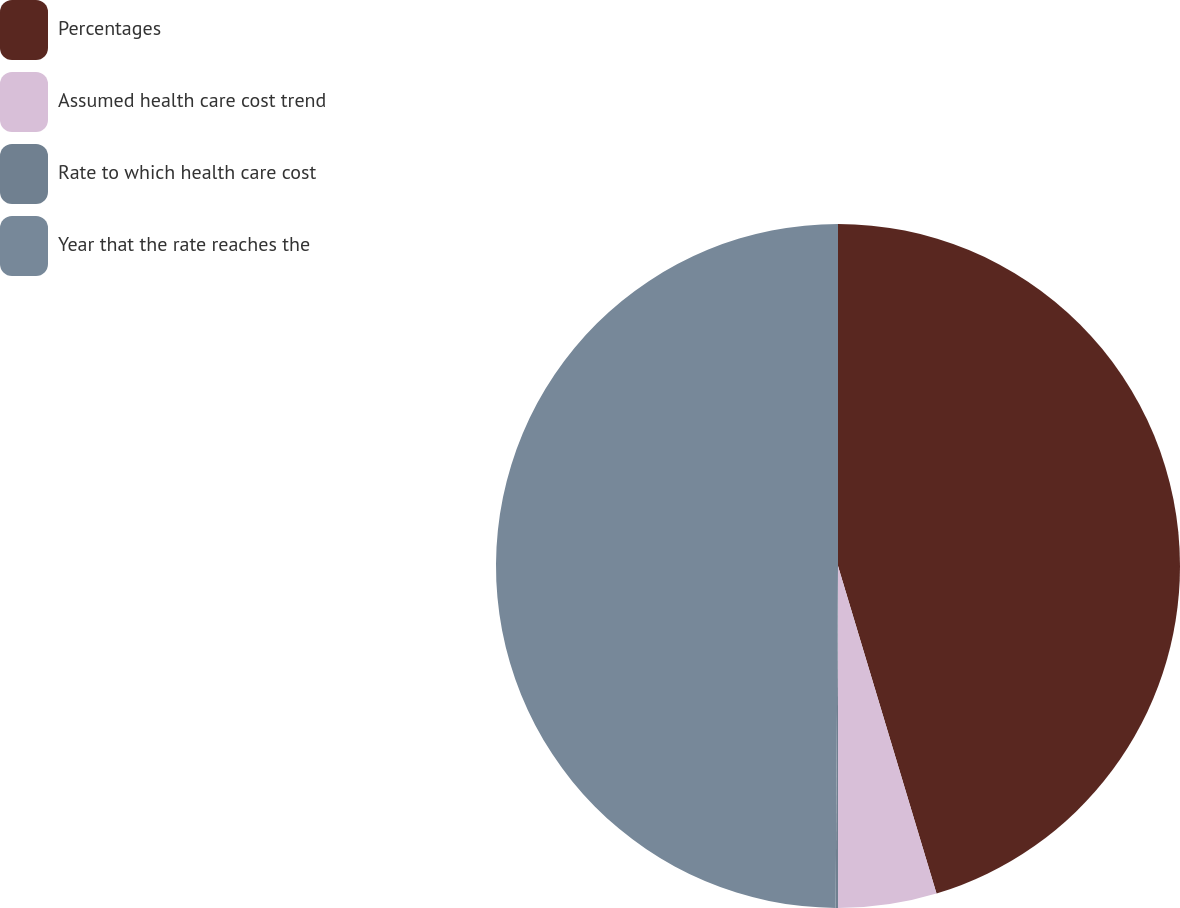Convert chart to OTSL. <chart><loc_0><loc_0><loc_500><loc_500><pie_chart><fcel>Percentages<fcel>Assumed health care cost trend<fcel>Rate to which health care cost<fcel>Year that the rate reaches the<nl><fcel>45.35%<fcel>4.65%<fcel>0.11%<fcel>49.89%<nl></chart> 